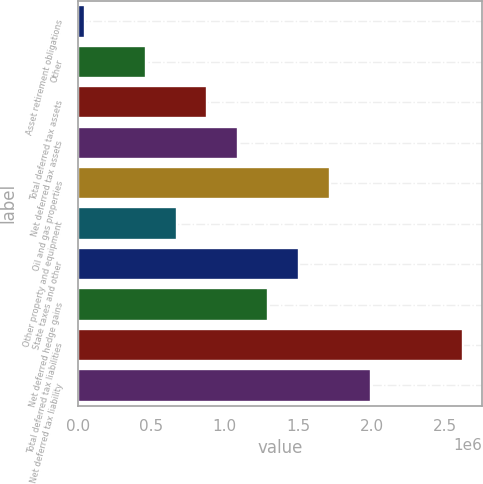<chart> <loc_0><loc_0><loc_500><loc_500><bar_chart><fcel>Asset retirement obligations<fcel>Other<fcel>Total deferred tax assets<fcel>Net deferred tax assets<fcel>Oil and gas properties<fcel>Other property and equipment<fcel>State taxes and other<fcel>Net deferred hedge gains<fcel>Total deferred tax liabilities<fcel>Net deferred tax liability<nl><fcel>47860<fcel>464457<fcel>881055<fcel>1.08935e+06<fcel>1.71425e+06<fcel>672756<fcel>1.50595e+06<fcel>1.29765e+06<fcel>2.62506e+06<fcel>2.00016e+06<nl></chart> 